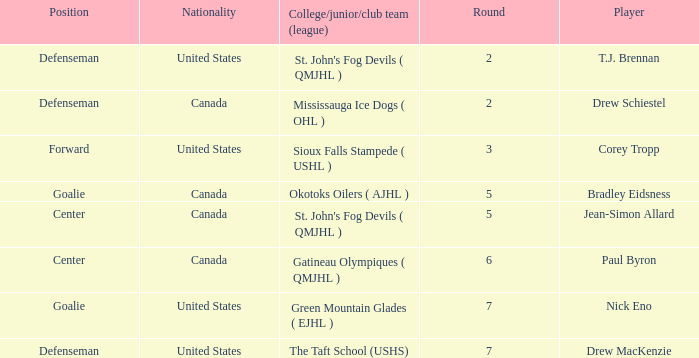Parse the full table. {'header': ['Position', 'Nationality', 'College/junior/club team (league)', 'Round', 'Player'], 'rows': [['Defenseman', 'United States', "St. John's Fog Devils ( QMJHL )", '2', 'T.J. Brennan'], ['Defenseman', 'Canada', 'Mississauga Ice Dogs ( OHL )', '2', 'Drew Schiestel'], ['Forward', 'United States', 'Sioux Falls Stampede ( USHL )', '3', 'Corey Tropp'], ['Goalie', 'Canada', 'Okotoks Oilers ( AJHL )', '5', 'Bradley Eidsness'], ['Center', 'Canada', "St. John's Fog Devils ( QMJHL )", '5', 'Jean-Simon Allard'], ['Center', 'Canada', 'Gatineau Olympiques ( QMJHL )', '6', 'Paul Byron'], ['Goalie', 'United States', 'Green Mountain Glades ( EJHL )', '7', 'Nick Eno'], ['Defenseman', 'United States', 'The Taft School (USHS)', '7', 'Drew MacKenzie']]} What is the nationality of the goalie in Round 7? United States. 